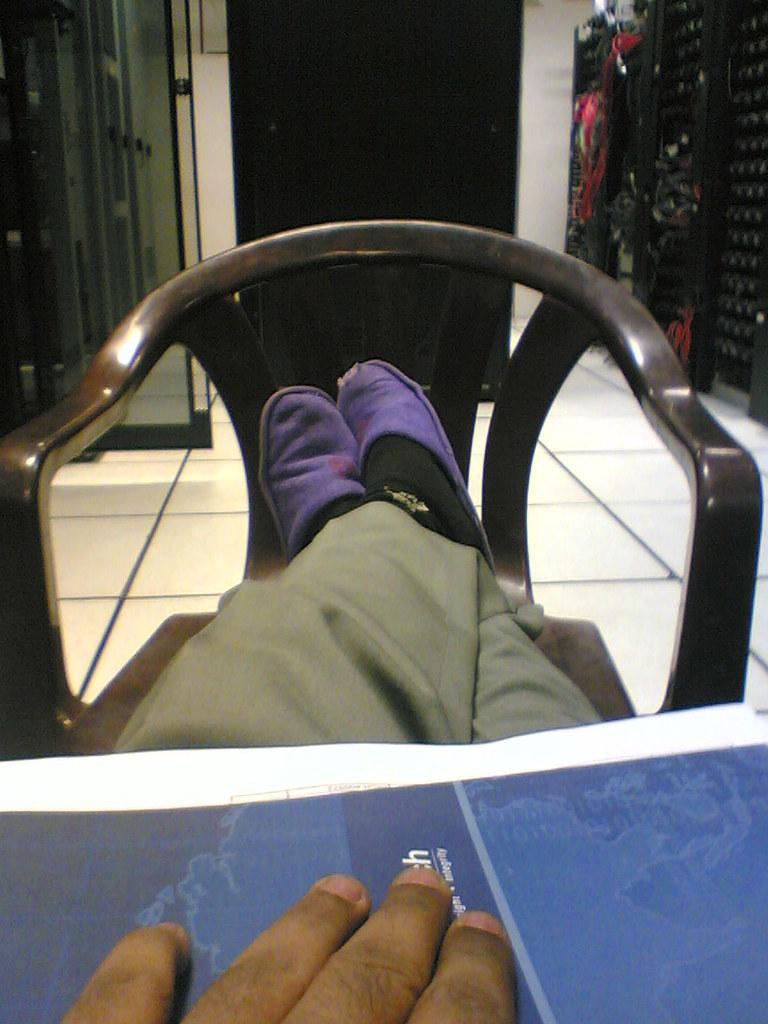What body part is visible on the chair in the image? There are a person's legs on a chair in the image. What can be seen on the table in the image? There is a table space visible in the image, and a person's hand and fingers are on the table space. What is visible in the background of the image? There is a wall with a door in the background of the image. What type of payment is being made on the person's chin in the image? There is no payment or chin present in the image; it only features a person's legs on a chair, a table space, and a wall with a door in the background. 